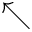<formula> <loc_0><loc_0><loc_500><loc_500>\nwarrow</formula> 